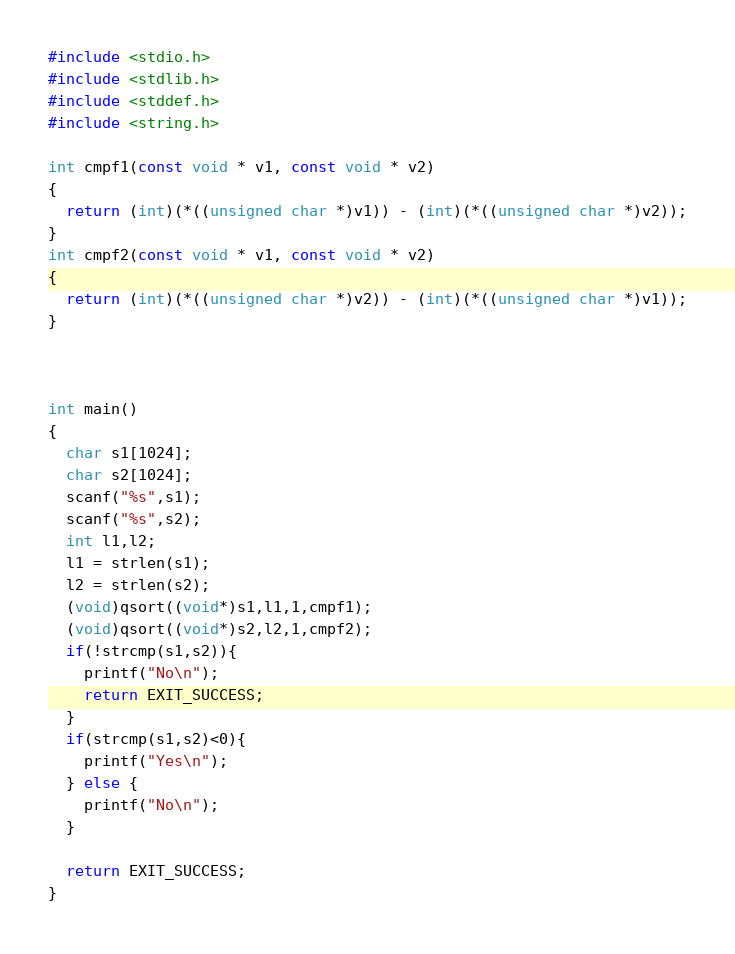<code> <loc_0><loc_0><loc_500><loc_500><_C_>#include <stdio.h>
#include <stdlib.h>
#include <stddef.h>
#include <string.h>

int cmpf1(const void * v1, const void * v2)
{
  return (int)(*((unsigned char *)v1)) - (int)(*((unsigned char *)v2));
}
int cmpf2(const void * v1, const void * v2)
{
  return (int)(*((unsigned char *)v2)) - (int)(*((unsigned char *)v1));
}



int main()
{
  char s1[1024];
  char s2[1024];
  scanf("%s",s1);
  scanf("%s",s2);
  int l1,l2;
  l1 = strlen(s1);
  l2 = strlen(s2);
  (void)qsort((void*)s1,l1,1,cmpf1);
  (void)qsort((void*)s2,l2,1,cmpf2);
  if(!strcmp(s1,s2)){
    printf("No\n");
    return EXIT_SUCCESS;
  }
  if(strcmp(s1,s2)<0){
    printf("Yes\n");
  } else {
    printf("No\n");
  }
  
  return EXIT_SUCCESS;
}


</code> 